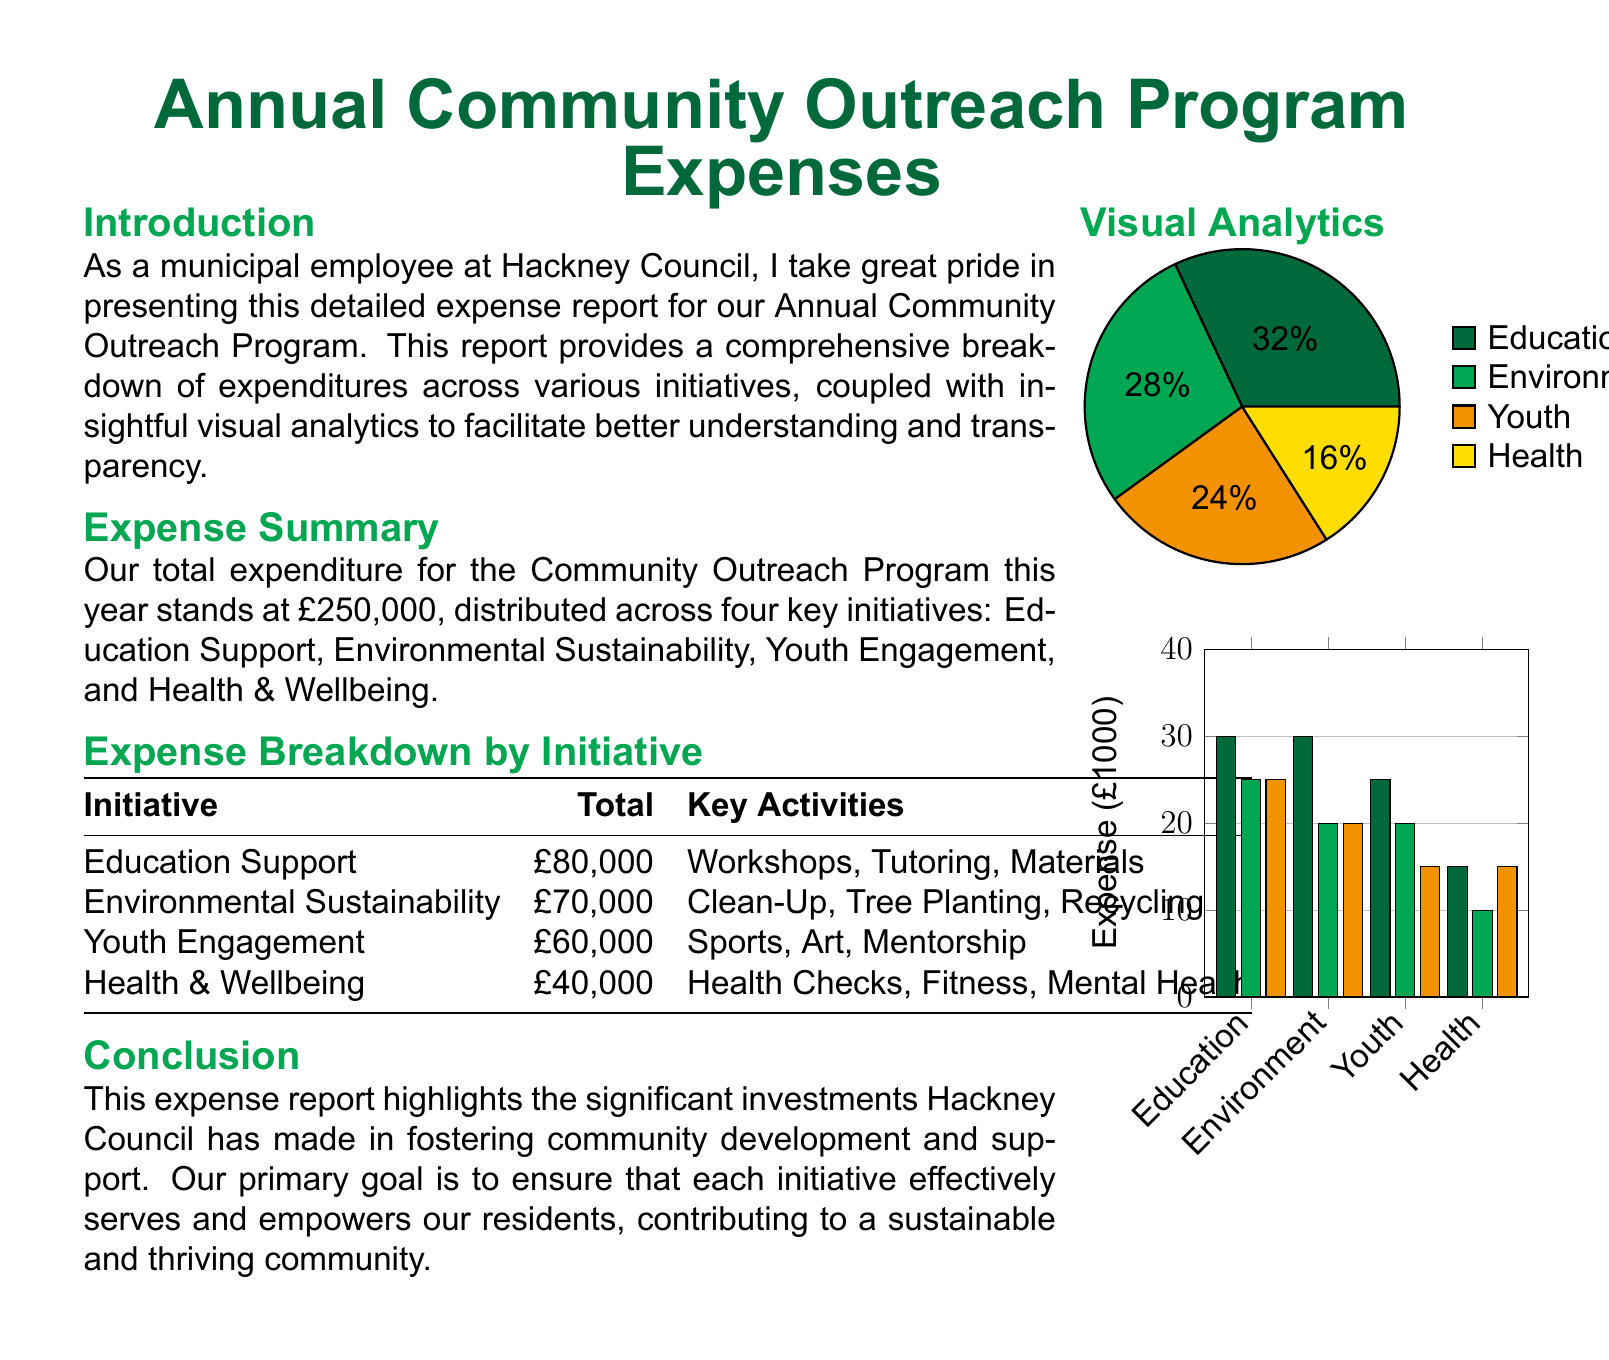What is the total expenditure for the Community Outreach Program? The total expenditure is explicitly stated in the document as £250,000.
Answer: £250,000 How much was spent on Education Support? The document provides a breakdown of expenses, indicating that Education Support received £80,000.
Answer: £80,000 What are the key activities for the Youth Engagement initiative? The document lists the key activities under Youth Engagement as Sports, Art, and Mentorship.
Answer: Sports, Art, Mentorship Which initiative received the least funding? By comparing the monetary amounts for each initiative, it is concluded that Health & Wellbeing received the least at £40,000.
Answer: Health & Wellbeing How many key initiatives are included in the report? The report outlines four key initiatives in the expense summary section.
Answer: Four What percentage of the total expenditure is allocated to Environmental Sustainability? Environmental Sustainability's funding is shown as £70,000, which is 28% of the total £250,000.
Answer: 28% What does the pie chart represent? The pie chart visually illustrates the percentage breakdown of expenses by initiative for the Community Outreach Program.
Answer: Percentage breakdown of expenses How much was spent on Health & Wellbeing initiatives? The document specifies that the expenditure for Health & Wellbeing is £40,000.
Answer: £40,000 What is the highest amount spent on a single initiative? By reviewing the expense breakdown, the highest amount spent on a single initiative is £80,000 for Education Support.
Answer: £80,000 